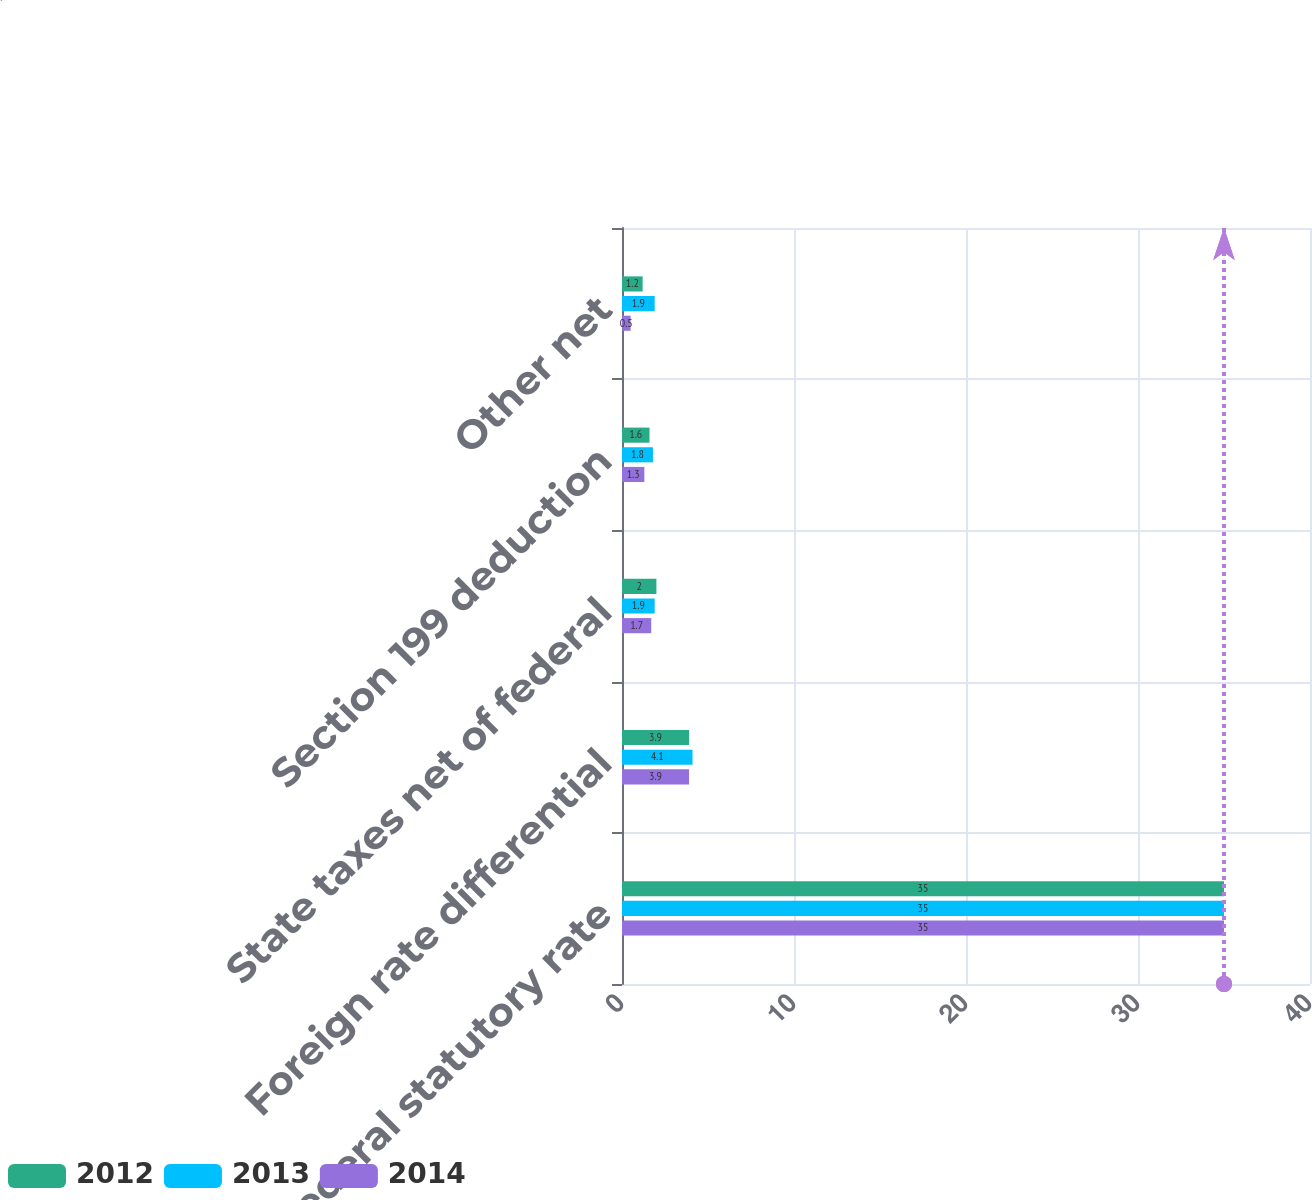Convert chart to OTSL. <chart><loc_0><loc_0><loc_500><loc_500><stacked_bar_chart><ecel><fcel>Federal statutory rate<fcel>Foreign rate differential<fcel>State taxes net of federal<fcel>Section 199 deduction<fcel>Other net<nl><fcel>2012<fcel>35<fcel>3.9<fcel>2<fcel>1.6<fcel>1.2<nl><fcel>2013<fcel>35<fcel>4.1<fcel>1.9<fcel>1.8<fcel>1.9<nl><fcel>2014<fcel>35<fcel>3.9<fcel>1.7<fcel>1.3<fcel>0.5<nl></chart> 